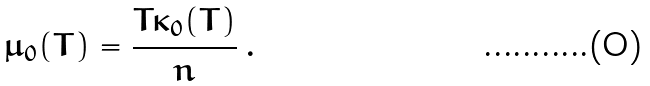<formula> <loc_0><loc_0><loc_500><loc_500>\mu _ { 0 } ( T ) = \frac { T \kappa _ { 0 } ( T ) } { n } \, .</formula> 